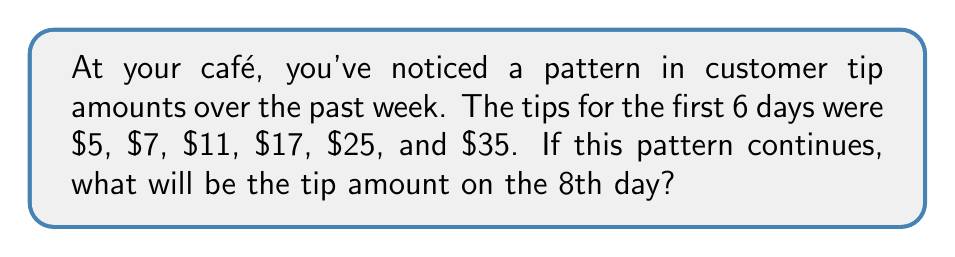Can you solve this math problem? To solve this problem, let's analyze the pattern in the given sequence:

$5, 7, 11, 17, 25, 35, ...$

Step 1: Calculate the differences between consecutive terms:
$7 - 5 = 2$
$11 - 7 = 4$
$17 - 11 = 6$
$25 - 17 = 8$
$35 - 25 = 10$

Step 2: Observe that the differences form an arithmetic sequence:
$2, 4, 6, 8, 10, ...$

The difference between these differences is constant: 2.

Step 3: Determine the general term for the difference sequence:
$a_n = 2n$, where $n$ is the position of the difference.

Step 4: Use this to find the next two terms in the original sequence:

For the 7th day:
$35 + (2 \cdot 6) = 35 + 12 = 47$

For the 8th day:
$47 + (2 \cdot 7) = 47 + 14 = 61$

Therefore, the tip amount on the 8th day will be $61.
Answer: $61 